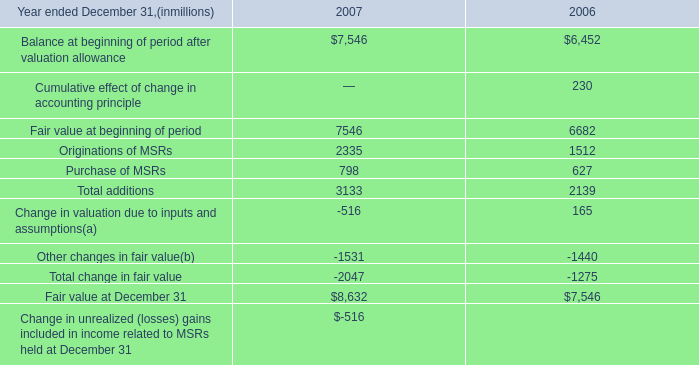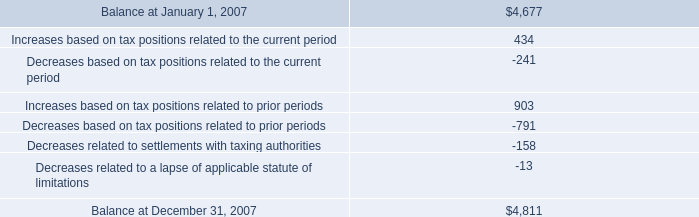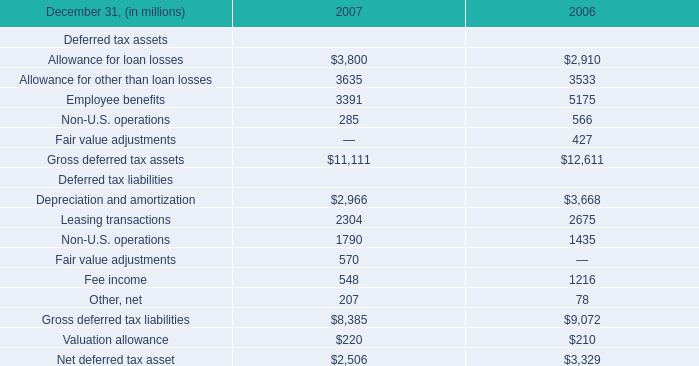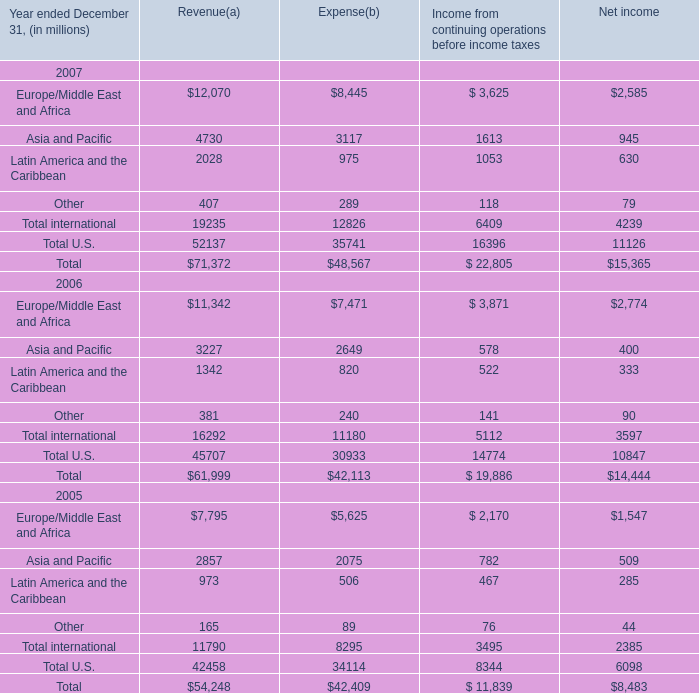What is the average value of Asia and Pacific of Revenue in Table 3 and Employee benefits in Table 2 in 2006? (in million) 
Computations: ((3227 + 5175) / 2)
Answer: 4201.0. 